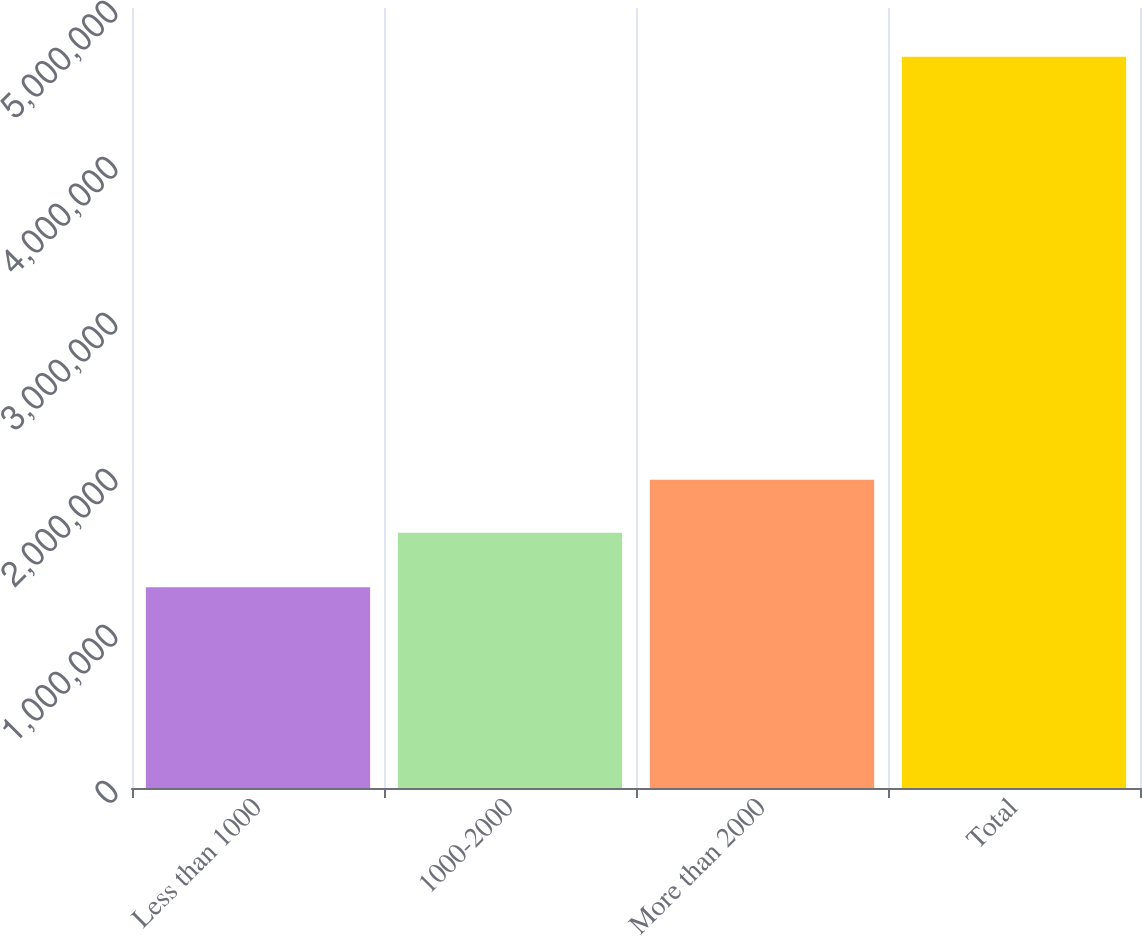<chart> <loc_0><loc_0><loc_500><loc_500><bar_chart><fcel>Less than 1000<fcel>1000-2000<fcel>More than 2000<fcel>Total<nl><fcel>1.28662e+06<fcel>1.63598e+06<fcel>1.976e+06<fcel>4.6868e+06<nl></chart> 